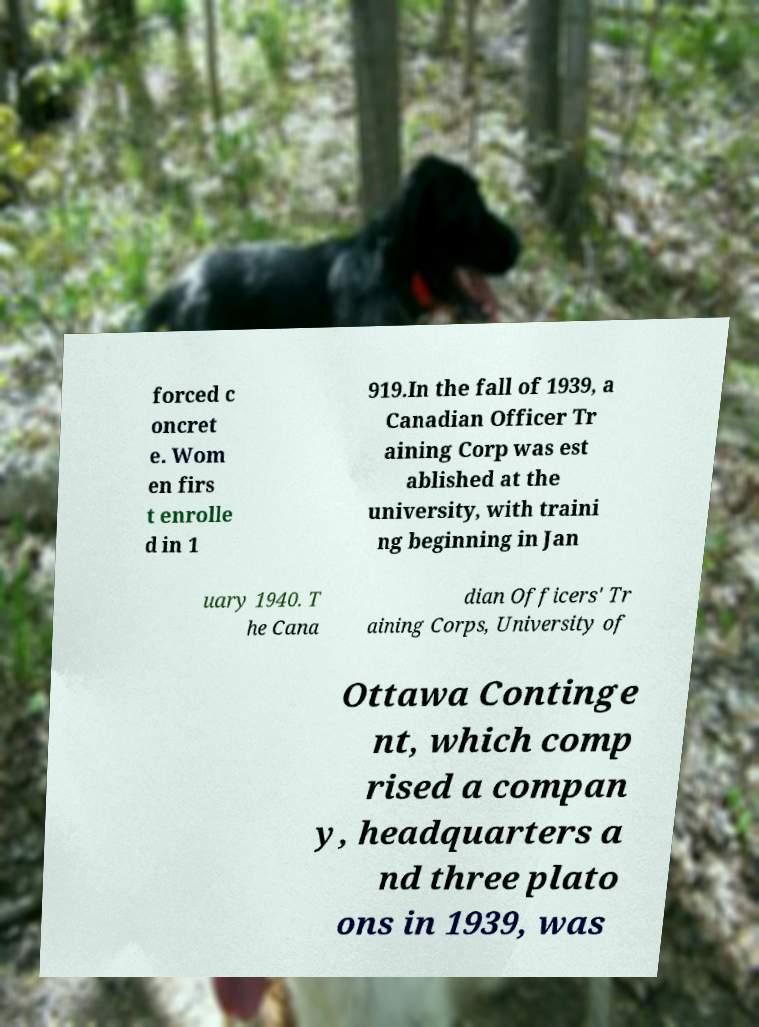There's text embedded in this image that I need extracted. Can you transcribe it verbatim? forced c oncret e. Wom en firs t enrolle d in 1 919.In the fall of 1939, a Canadian Officer Tr aining Corp was est ablished at the university, with traini ng beginning in Jan uary 1940. T he Cana dian Officers' Tr aining Corps, University of Ottawa Continge nt, which comp rised a compan y, headquarters a nd three plato ons in 1939, was 